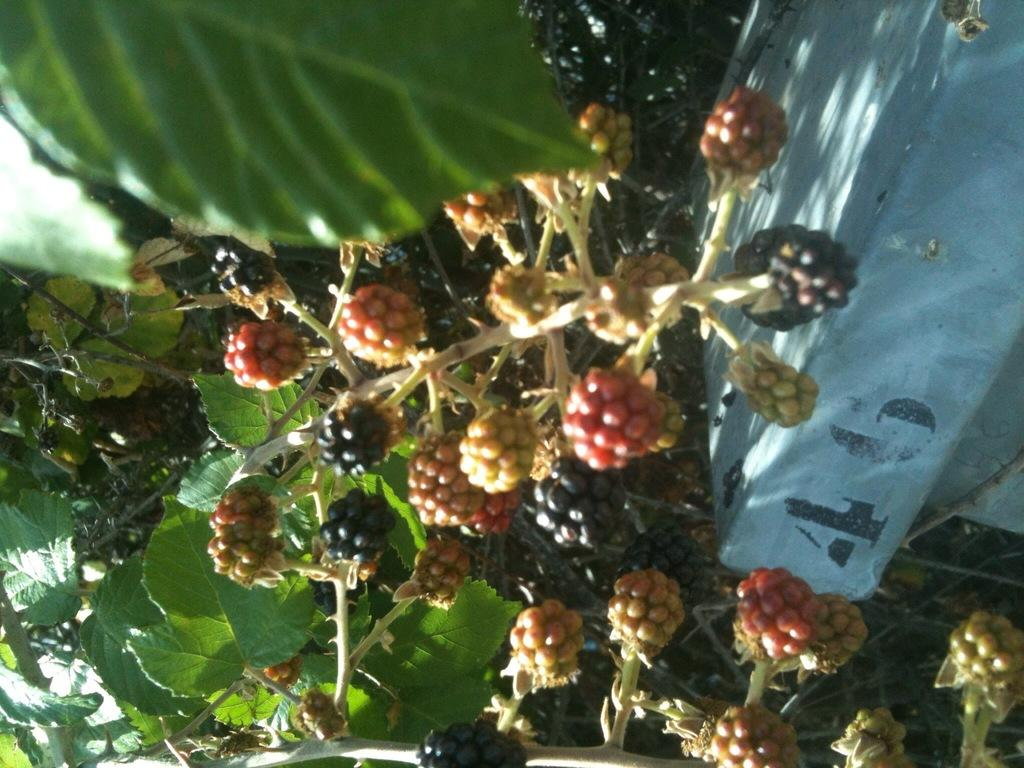What type of plant is visible in the image? There is a plant with berries in the image. What else can be seen in the image besides the plant? The image appears to show a wall. What type of mist can be seen surrounding the plant in the image? There is no mist present in the image; it only shows a plant with berries and a wall. 